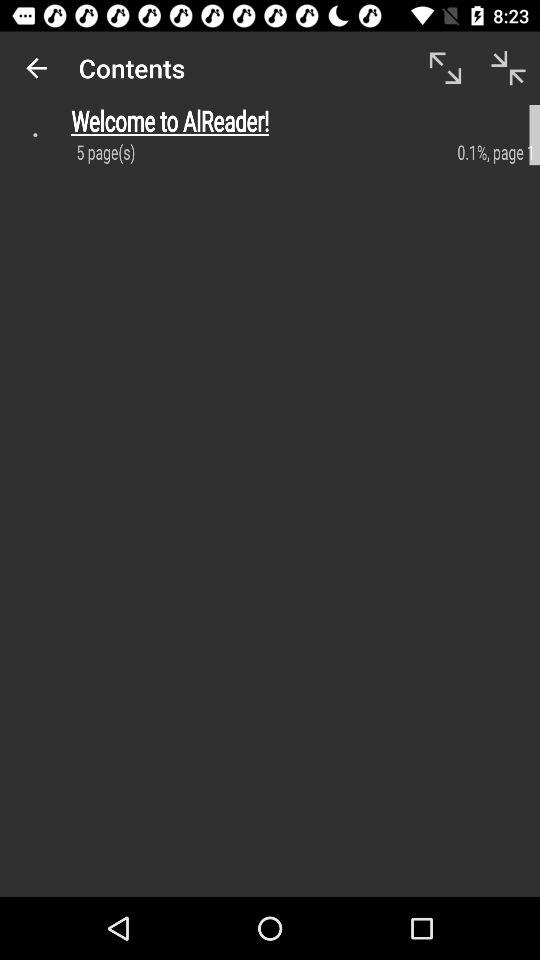How many percent of the document is loaded?
Answer the question using a single word or phrase. 0.1% 